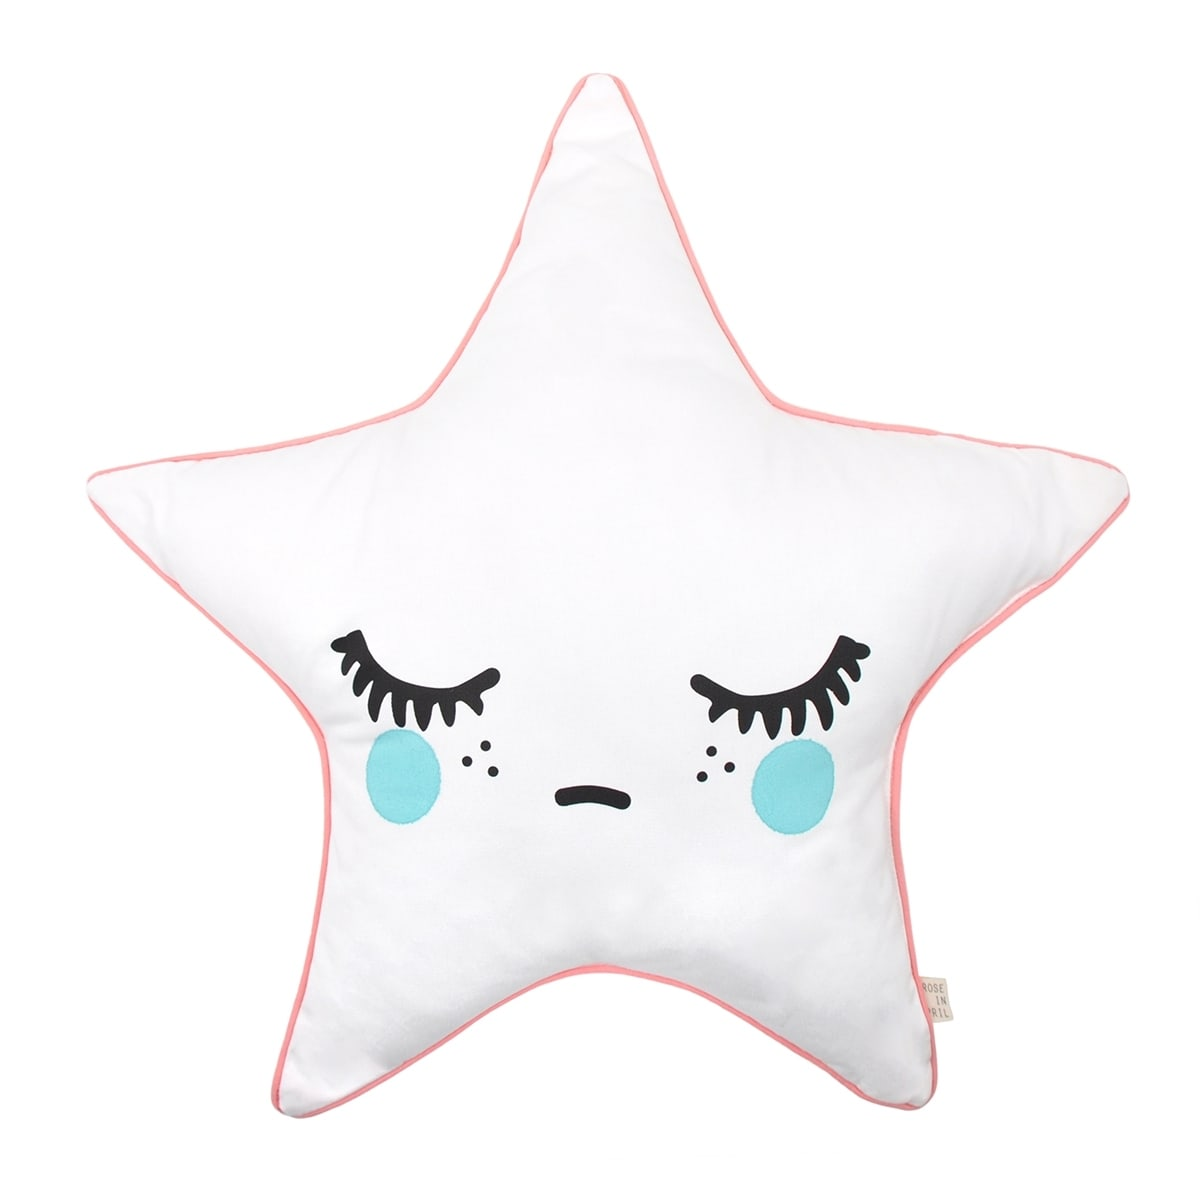Imagine this pillow is part of a bigger theme in a baby's nursery. What other elements could complement its design? To complement this pillow in a baby's nursery, you could include other whimsical and comforting elements. Consider adding a soft, star-themed mobile hanging above the crib, blankets with star patterns, and walls painted in pastel colors with moon and star decals. Plush toys featuring similar sleepy expressions could be placed around the room. A nightlight in the shape of a star or moon would enhance the nighttime ambiance. Overall, incorporating a celestial theme with matching decor could create a cohesive and charming nursery filled with night sky wonders. 